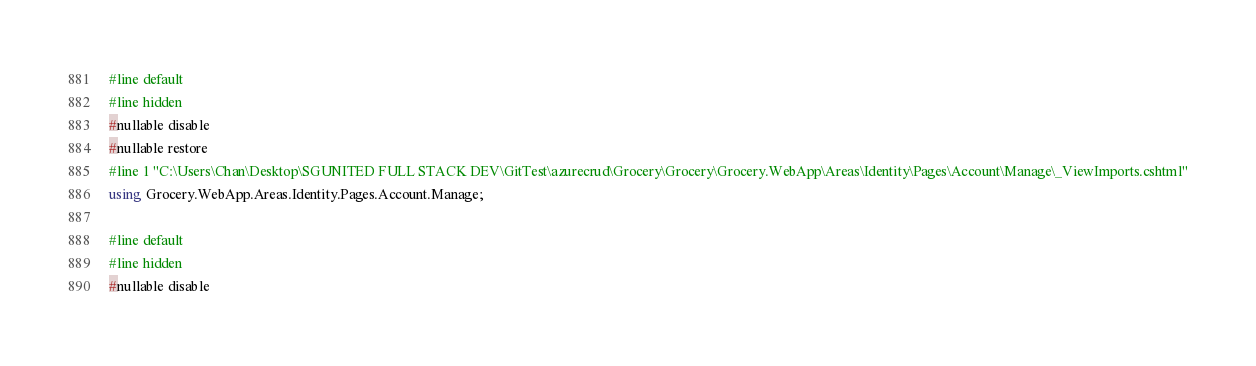Convert code to text. <code><loc_0><loc_0><loc_500><loc_500><_C#_>
#line default
#line hidden
#nullable disable
#nullable restore
#line 1 "C:\Users\Chan\Desktop\SGUNITED FULL STACK DEV\GitTest\azurecrud\Grocery\Grocery\Grocery.WebApp\Areas\Identity\Pages\Account\Manage\_ViewImports.cshtml"
using Grocery.WebApp.Areas.Identity.Pages.Account.Manage;

#line default
#line hidden
#nullable disable</code> 